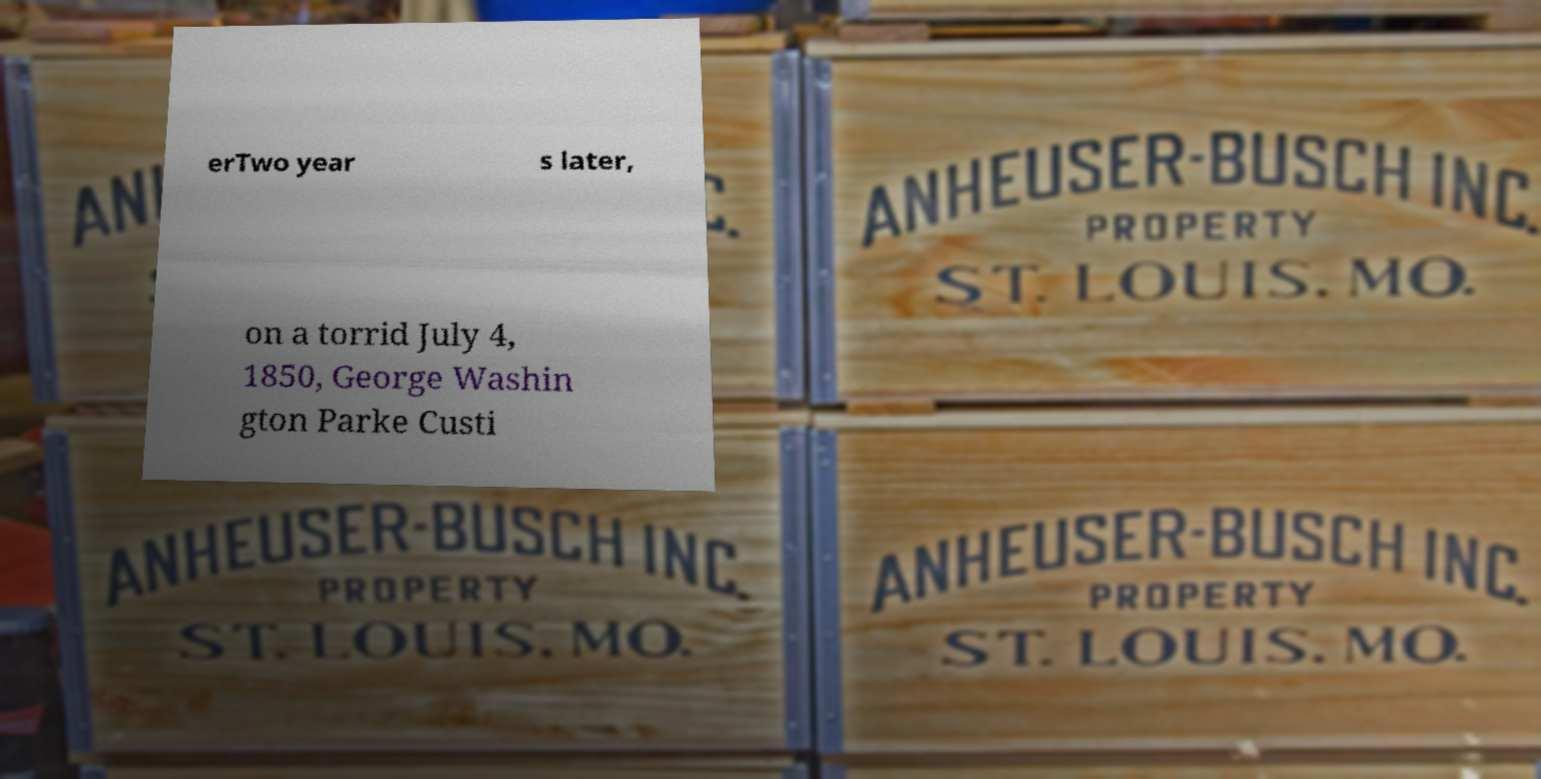Could you extract and type out the text from this image? erTwo year s later, on a torrid July 4, 1850, George Washin gton Parke Custi 